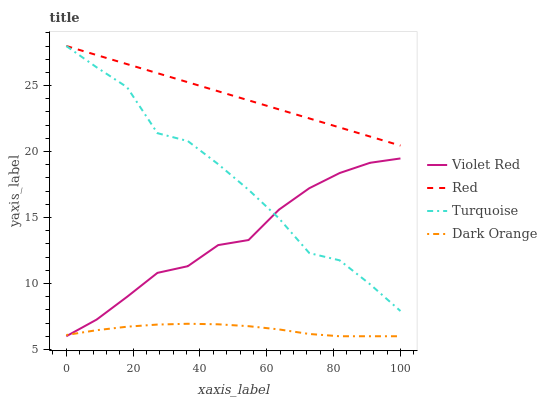Does Violet Red have the minimum area under the curve?
Answer yes or no. No. Does Violet Red have the maximum area under the curve?
Answer yes or no. No. Is Violet Red the smoothest?
Answer yes or no. No. Is Violet Red the roughest?
Answer yes or no. No. Does Turquoise have the lowest value?
Answer yes or no. No. Does Violet Red have the highest value?
Answer yes or no. No. Is Violet Red less than Red?
Answer yes or no. Yes. Is Turquoise greater than Dark Orange?
Answer yes or no. Yes. Does Violet Red intersect Red?
Answer yes or no. No. 